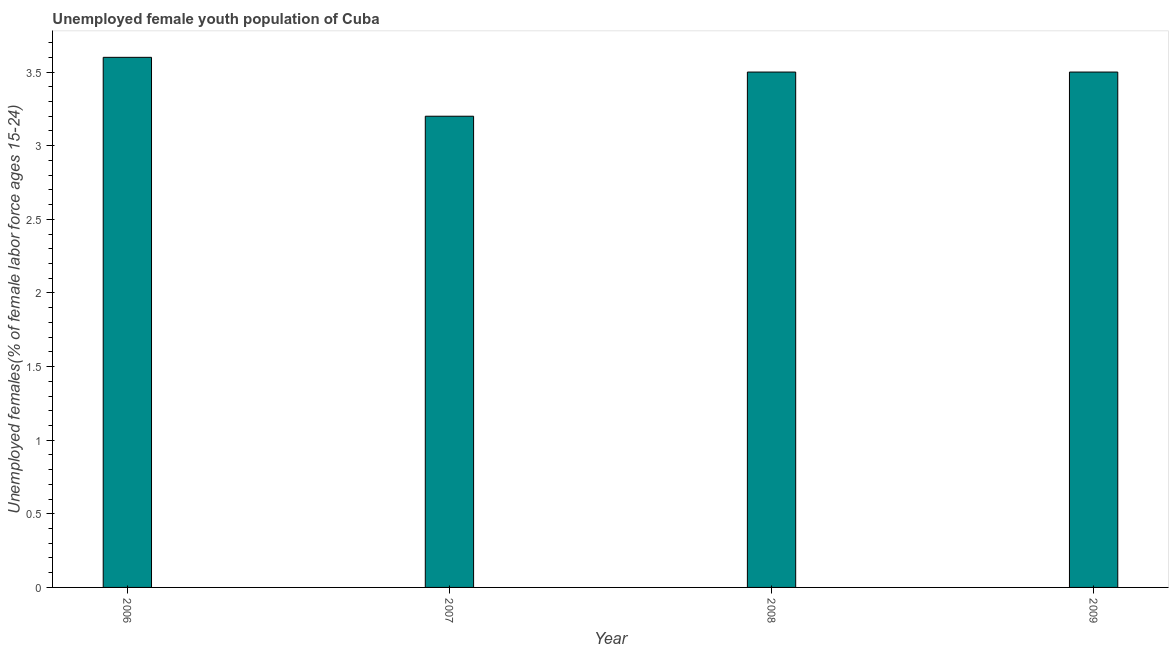Does the graph contain any zero values?
Provide a succinct answer. No. What is the title of the graph?
Make the answer very short. Unemployed female youth population of Cuba. What is the label or title of the Y-axis?
Keep it short and to the point. Unemployed females(% of female labor force ages 15-24). Across all years, what is the maximum unemployed female youth?
Your response must be concise. 3.6. Across all years, what is the minimum unemployed female youth?
Give a very brief answer. 3.2. In which year was the unemployed female youth maximum?
Keep it short and to the point. 2006. In which year was the unemployed female youth minimum?
Make the answer very short. 2007. What is the sum of the unemployed female youth?
Ensure brevity in your answer.  13.8. What is the average unemployed female youth per year?
Offer a terse response. 3.45. What is the median unemployed female youth?
Offer a terse response. 3.5. In how many years, is the unemployed female youth greater than 1.8 %?
Offer a terse response. 4. Is the unemployed female youth in 2006 less than that in 2009?
Your answer should be compact. No. What is the difference between the highest and the second highest unemployed female youth?
Give a very brief answer. 0.1. Is the sum of the unemployed female youth in 2007 and 2009 greater than the maximum unemployed female youth across all years?
Your response must be concise. Yes. What is the difference between the highest and the lowest unemployed female youth?
Ensure brevity in your answer.  0.4. Are all the bars in the graph horizontal?
Provide a succinct answer. No. What is the difference between two consecutive major ticks on the Y-axis?
Provide a short and direct response. 0.5. Are the values on the major ticks of Y-axis written in scientific E-notation?
Ensure brevity in your answer.  No. What is the Unemployed females(% of female labor force ages 15-24) of 2006?
Your answer should be very brief. 3.6. What is the Unemployed females(% of female labor force ages 15-24) of 2007?
Give a very brief answer. 3.2. What is the Unemployed females(% of female labor force ages 15-24) in 2008?
Provide a succinct answer. 3.5. What is the difference between the Unemployed females(% of female labor force ages 15-24) in 2006 and 2007?
Make the answer very short. 0.4. What is the difference between the Unemployed females(% of female labor force ages 15-24) in 2006 and 2008?
Offer a very short reply. 0.1. What is the ratio of the Unemployed females(% of female labor force ages 15-24) in 2006 to that in 2007?
Make the answer very short. 1.12. What is the ratio of the Unemployed females(% of female labor force ages 15-24) in 2006 to that in 2008?
Your response must be concise. 1.03. What is the ratio of the Unemployed females(% of female labor force ages 15-24) in 2007 to that in 2008?
Keep it short and to the point. 0.91. What is the ratio of the Unemployed females(% of female labor force ages 15-24) in 2007 to that in 2009?
Ensure brevity in your answer.  0.91. What is the ratio of the Unemployed females(% of female labor force ages 15-24) in 2008 to that in 2009?
Your answer should be compact. 1. 